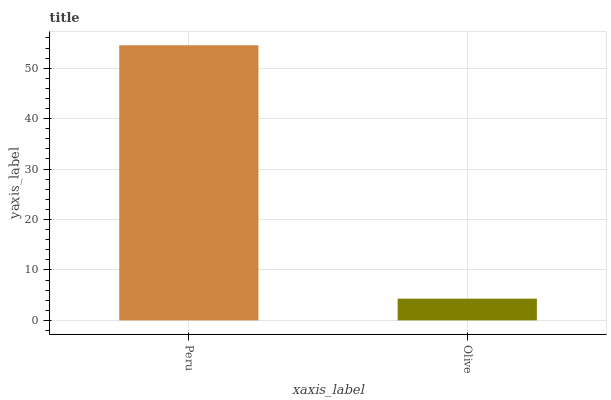Is Olive the maximum?
Answer yes or no. No. Is Peru greater than Olive?
Answer yes or no. Yes. Is Olive less than Peru?
Answer yes or no. Yes. Is Olive greater than Peru?
Answer yes or no. No. Is Peru less than Olive?
Answer yes or no. No. Is Peru the high median?
Answer yes or no. Yes. Is Olive the low median?
Answer yes or no. Yes. Is Olive the high median?
Answer yes or no. No. Is Peru the low median?
Answer yes or no. No. 